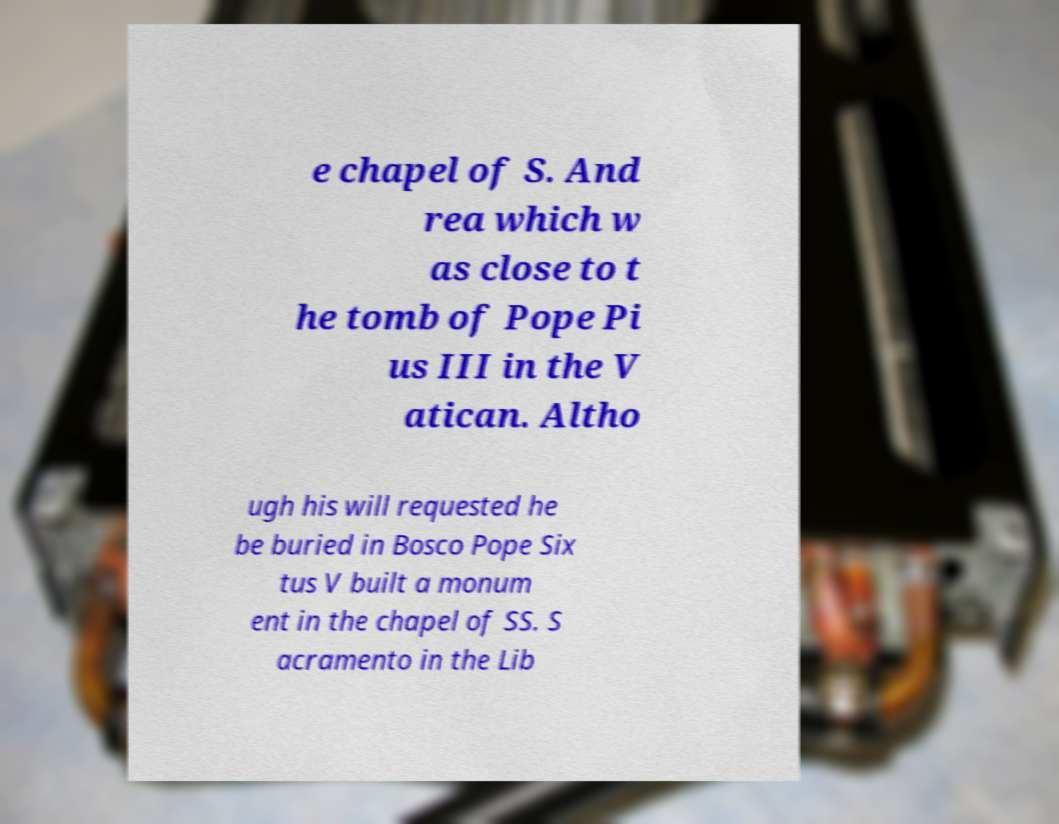Can you accurately transcribe the text from the provided image for me? e chapel of S. And rea which w as close to t he tomb of Pope Pi us III in the V atican. Altho ugh his will requested he be buried in Bosco Pope Six tus V built a monum ent in the chapel of SS. S acramento in the Lib 